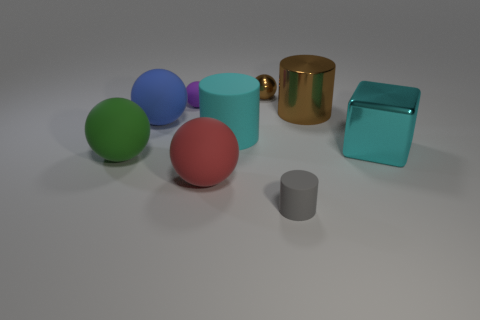Are there more blue spheres to the right of the large shiny cylinder than cyan cylinders that are to the right of the blue rubber sphere?
Keep it short and to the point. No. Is the shape of the large brown metal object the same as the metallic thing in front of the big blue object?
Provide a succinct answer. No. What number of other things are the same shape as the large green thing?
Give a very brief answer. 4. What color is the tiny thing that is on the right side of the cyan matte object and behind the big cyan shiny block?
Offer a very short reply. Brown. The tiny cylinder is what color?
Provide a short and direct response. Gray. Is the green sphere made of the same material as the small thing in front of the block?
Make the answer very short. Yes. What is the shape of the cyan object that is made of the same material as the gray thing?
Your answer should be compact. Cylinder. What color is the other shiny thing that is the same size as the gray object?
Offer a terse response. Brown. There is a metal object in front of the blue object; does it have the same size as the blue rubber thing?
Provide a short and direct response. Yes. Is the metallic cylinder the same color as the big cube?
Make the answer very short. No. 